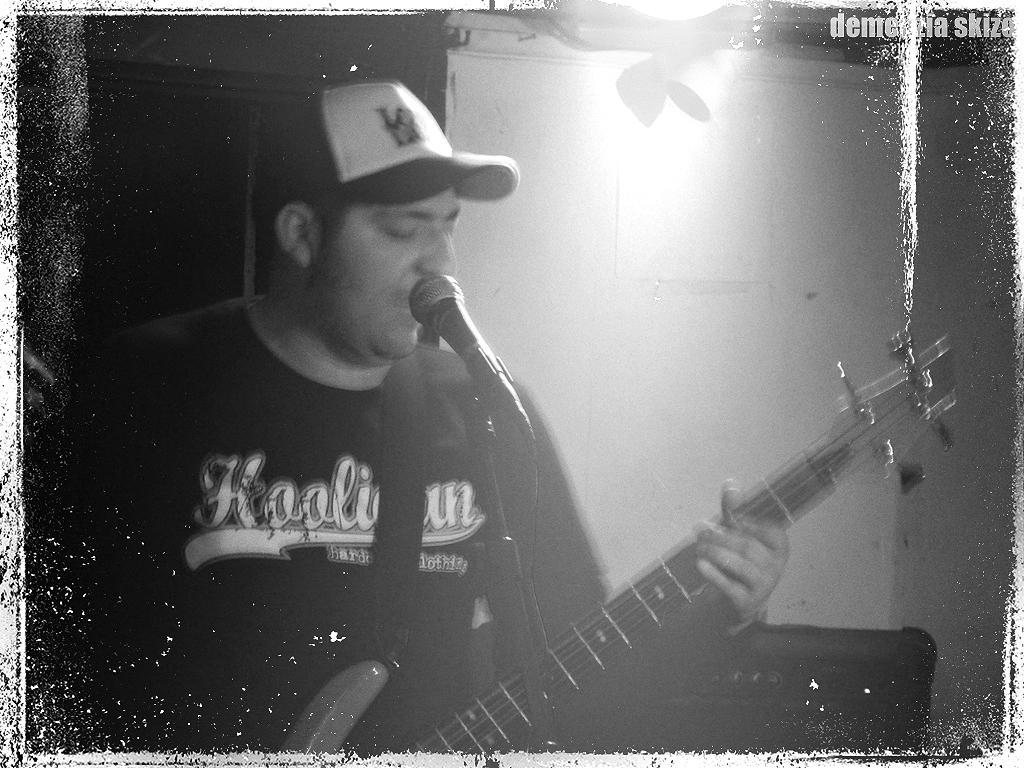Who is the main subject in the image? There is a man in the image. Where is the man located in the image? The man is on the right side of the image. What is the man wearing in the image? The man is wearing a t-shirt and a cap. What is the man doing in the image? The man is singing and playing a guitar. What can be seen in the background of the image? There is a wall in the background of the image. What type of wine is the man drinking in the image? There is no wine present in the image; the man is playing a guitar and singing. 